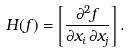Convert formula to latex. <formula><loc_0><loc_0><loc_500><loc_500>H ( f ) = \left [ { \frac { \partial ^ { 2 } f } { \partial x _ { i } \, \partial x _ { j } } } \right ] .</formula> 